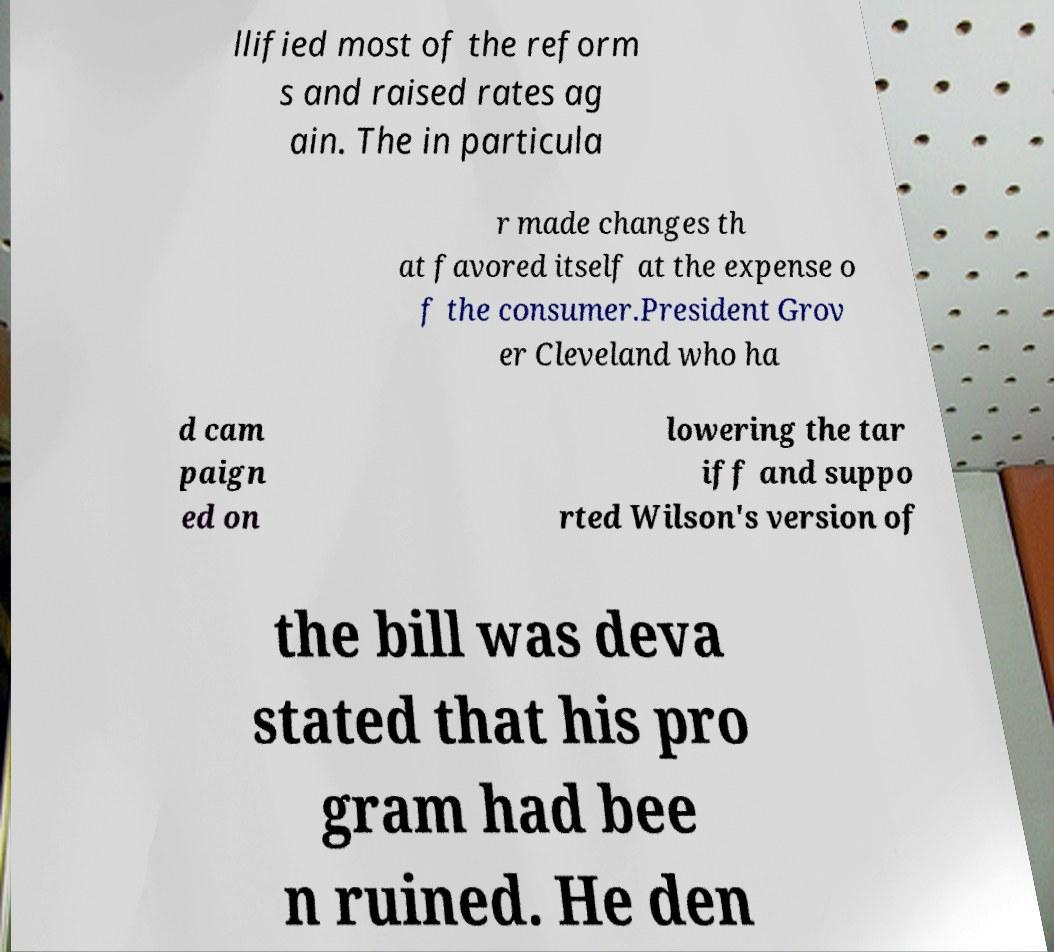There's text embedded in this image that I need extracted. Can you transcribe it verbatim? llified most of the reform s and raised rates ag ain. The in particula r made changes th at favored itself at the expense o f the consumer.President Grov er Cleveland who ha d cam paign ed on lowering the tar iff and suppo rted Wilson's version of the bill was deva stated that his pro gram had bee n ruined. He den 